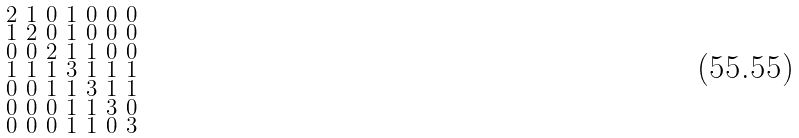Convert formula to latex. <formula><loc_0><loc_0><loc_500><loc_500>\begin{smallmatrix} 2 & 1 & 0 & 1 & 0 & 0 & 0 \\ 1 & 2 & 0 & 1 & 0 & 0 & 0 \\ 0 & 0 & 2 & 1 & 1 & 0 & 0 \\ 1 & 1 & 1 & 3 & 1 & 1 & 1 \\ 0 & 0 & 1 & 1 & 3 & 1 & 1 \\ 0 & 0 & 0 & 1 & 1 & 3 & 0 \\ 0 & 0 & 0 & 1 & 1 & 0 & 3 \end{smallmatrix}</formula> 